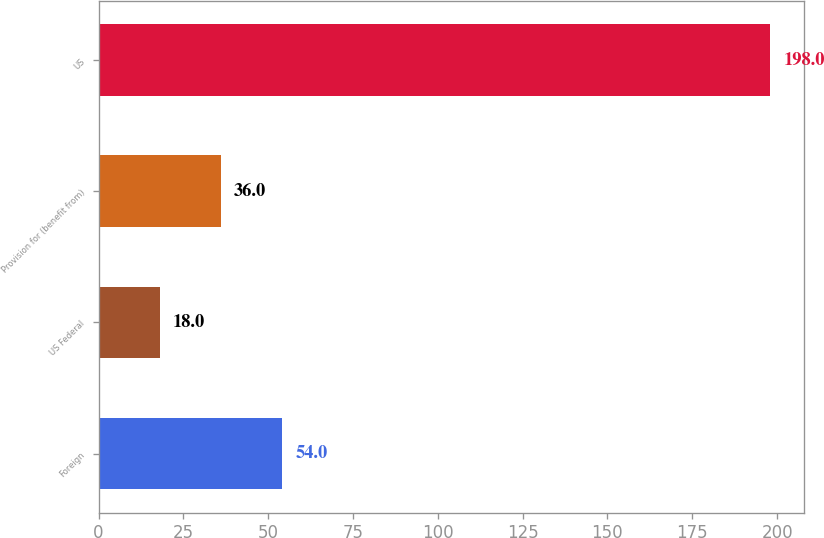Convert chart to OTSL. <chart><loc_0><loc_0><loc_500><loc_500><bar_chart><fcel>Foreign<fcel>US Federal<fcel>Provision for (benefit from)<fcel>US<nl><fcel>54<fcel>18<fcel>36<fcel>198<nl></chart> 